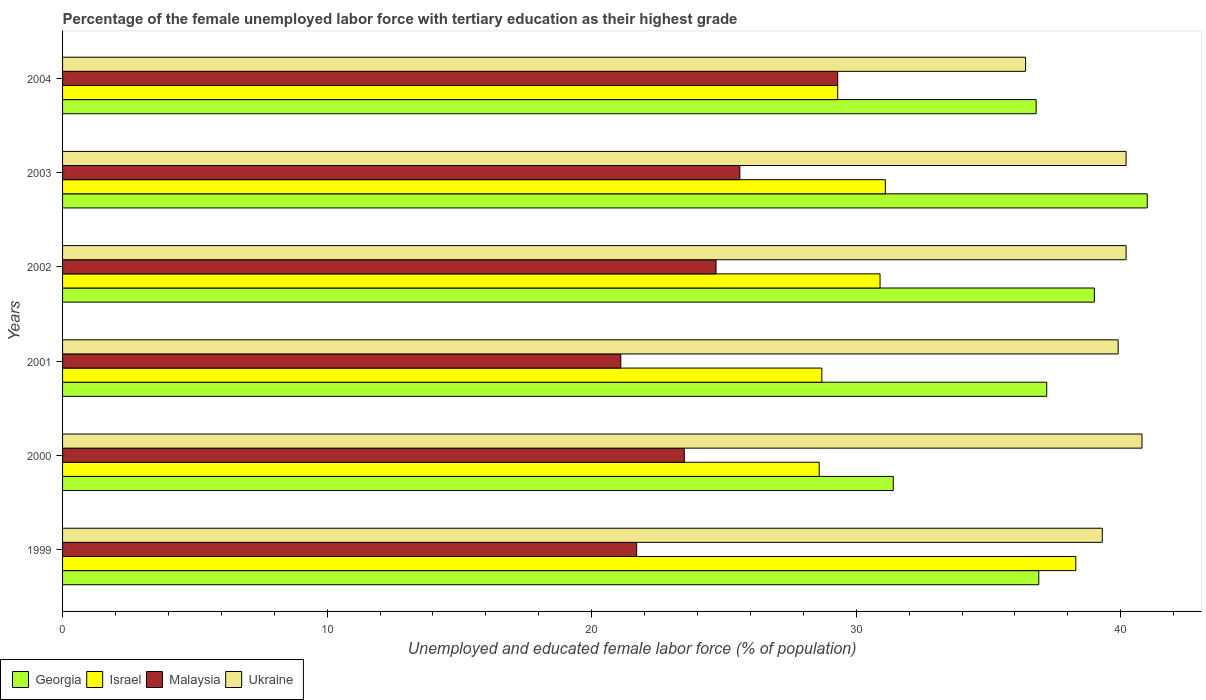How many groups of bars are there?
Provide a succinct answer. 6. In how many cases, is the number of bars for a given year not equal to the number of legend labels?
Ensure brevity in your answer.  0. What is the percentage of the unemployed female labor force with tertiary education in Georgia in 2000?
Make the answer very short. 31.4. Across all years, what is the maximum percentage of the unemployed female labor force with tertiary education in Malaysia?
Make the answer very short. 29.3. Across all years, what is the minimum percentage of the unemployed female labor force with tertiary education in Ukraine?
Ensure brevity in your answer.  36.4. In which year was the percentage of the unemployed female labor force with tertiary education in Israel maximum?
Your response must be concise. 1999. In which year was the percentage of the unemployed female labor force with tertiary education in Israel minimum?
Ensure brevity in your answer.  2000. What is the total percentage of the unemployed female labor force with tertiary education in Malaysia in the graph?
Offer a very short reply. 145.9. What is the difference between the percentage of the unemployed female labor force with tertiary education in Israel in 1999 and that in 2004?
Give a very brief answer. 9. What is the difference between the percentage of the unemployed female labor force with tertiary education in Malaysia in 2003 and the percentage of the unemployed female labor force with tertiary education in Ukraine in 2002?
Make the answer very short. -14.6. What is the average percentage of the unemployed female labor force with tertiary education in Ukraine per year?
Ensure brevity in your answer.  39.47. In the year 2004, what is the difference between the percentage of the unemployed female labor force with tertiary education in Malaysia and percentage of the unemployed female labor force with tertiary education in Ukraine?
Provide a short and direct response. -7.1. What is the ratio of the percentage of the unemployed female labor force with tertiary education in Georgia in 2000 to that in 2001?
Your response must be concise. 0.84. What is the difference between the highest and the lowest percentage of the unemployed female labor force with tertiary education in Malaysia?
Give a very brief answer. 8.2. What does the 1st bar from the top in 2004 represents?
Provide a short and direct response. Ukraine. Is it the case that in every year, the sum of the percentage of the unemployed female labor force with tertiary education in Israel and percentage of the unemployed female labor force with tertiary education in Georgia is greater than the percentage of the unemployed female labor force with tertiary education in Malaysia?
Keep it short and to the point. Yes. How many bars are there?
Your answer should be compact. 24. Are all the bars in the graph horizontal?
Your answer should be compact. Yes. How many years are there in the graph?
Your response must be concise. 6. What is the difference between two consecutive major ticks on the X-axis?
Your answer should be compact. 10. Are the values on the major ticks of X-axis written in scientific E-notation?
Give a very brief answer. No. Does the graph contain grids?
Make the answer very short. No. How many legend labels are there?
Offer a very short reply. 4. What is the title of the graph?
Offer a very short reply. Percentage of the female unemployed labor force with tertiary education as their highest grade. Does "Saudi Arabia" appear as one of the legend labels in the graph?
Provide a short and direct response. No. What is the label or title of the X-axis?
Offer a terse response. Unemployed and educated female labor force (% of population). What is the label or title of the Y-axis?
Ensure brevity in your answer.  Years. What is the Unemployed and educated female labor force (% of population) in Georgia in 1999?
Your answer should be very brief. 36.9. What is the Unemployed and educated female labor force (% of population) in Israel in 1999?
Keep it short and to the point. 38.3. What is the Unemployed and educated female labor force (% of population) in Malaysia in 1999?
Offer a terse response. 21.7. What is the Unemployed and educated female labor force (% of population) in Ukraine in 1999?
Provide a succinct answer. 39.3. What is the Unemployed and educated female labor force (% of population) in Georgia in 2000?
Provide a succinct answer. 31.4. What is the Unemployed and educated female labor force (% of population) in Israel in 2000?
Your answer should be compact. 28.6. What is the Unemployed and educated female labor force (% of population) of Ukraine in 2000?
Provide a short and direct response. 40.8. What is the Unemployed and educated female labor force (% of population) of Georgia in 2001?
Your answer should be very brief. 37.2. What is the Unemployed and educated female labor force (% of population) in Israel in 2001?
Offer a very short reply. 28.7. What is the Unemployed and educated female labor force (% of population) of Malaysia in 2001?
Your answer should be compact. 21.1. What is the Unemployed and educated female labor force (% of population) in Ukraine in 2001?
Offer a terse response. 39.9. What is the Unemployed and educated female labor force (% of population) in Georgia in 2002?
Your response must be concise. 39. What is the Unemployed and educated female labor force (% of population) in Israel in 2002?
Keep it short and to the point. 30.9. What is the Unemployed and educated female labor force (% of population) in Malaysia in 2002?
Offer a terse response. 24.7. What is the Unemployed and educated female labor force (% of population) in Ukraine in 2002?
Offer a very short reply. 40.2. What is the Unemployed and educated female labor force (% of population) of Georgia in 2003?
Keep it short and to the point. 41. What is the Unemployed and educated female labor force (% of population) in Israel in 2003?
Your answer should be compact. 31.1. What is the Unemployed and educated female labor force (% of population) in Malaysia in 2003?
Your response must be concise. 25.6. What is the Unemployed and educated female labor force (% of population) in Ukraine in 2003?
Provide a short and direct response. 40.2. What is the Unemployed and educated female labor force (% of population) of Georgia in 2004?
Offer a very short reply. 36.8. What is the Unemployed and educated female labor force (% of population) of Israel in 2004?
Keep it short and to the point. 29.3. What is the Unemployed and educated female labor force (% of population) of Malaysia in 2004?
Provide a short and direct response. 29.3. What is the Unemployed and educated female labor force (% of population) in Ukraine in 2004?
Your answer should be compact. 36.4. Across all years, what is the maximum Unemployed and educated female labor force (% of population) in Georgia?
Offer a terse response. 41. Across all years, what is the maximum Unemployed and educated female labor force (% of population) of Israel?
Provide a succinct answer. 38.3. Across all years, what is the maximum Unemployed and educated female labor force (% of population) in Malaysia?
Offer a terse response. 29.3. Across all years, what is the maximum Unemployed and educated female labor force (% of population) of Ukraine?
Provide a short and direct response. 40.8. Across all years, what is the minimum Unemployed and educated female labor force (% of population) of Georgia?
Ensure brevity in your answer.  31.4. Across all years, what is the minimum Unemployed and educated female labor force (% of population) in Israel?
Give a very brief answer. 28.6. Across all years, what is the minimum Unemployed and educated female labor force (% of population) in Malaysia?
Provide a short and direct response. 21.1. Across all years, what is the minimum Unemployed and educated female labor force (% of population) of Ukraine?
Ensure brevity in your answer.  36.4. What is the total Unemployed and educated female labor force (% of population) of Georgia in the graph?
Your answer should be very brief. 222.3. What is the total Unemployed and educated female labor force (% of population) of Israel in the graph?
Give a very brief answer. 186.9. What is the total Unemployed and educated female labor force (% of population) in Malaysia in the graph?
Ensure brevity in your answer.  145.9. What is the total Unemployed and educated female labor force (% of population) in Ukraine in the graph?
Make the answer very short. 236.8. What is the difference between the Unemployed and educated female labor force (% of population) in Israel in 1999 and that in 2000?
Provide a succinct answer. 9.7. What is the difference between the Unemployed and educated female labor force (% of population) of Malaysia in 1999 and that in 2000?
Your response must be concise. -1.8. What is the difference between the Unemployed and educated female labor force (% of population) in Ukraine in 1999 and that in 2000?
Ensure brevity in your answer.  -1.5. What is the difference between the Unemployed and educated female labor force (% of population) in Israel in 1999 and that in 2001?
Offer a very short reply. 9.6. What is the difference between the Unemployed and educated female labor force (% of population) of Israel in 1999 and that in 2002?
Make the answer very short. 7.4. What is the difference between the Unemployed and educated female labor force (% of population) of Malaysia in 1999 and that in 2003?
Provide a short and direct response. -3.9. What is the difference between the Unemployed and educated female labor force (% of population) in Ukraine in 1999 and that in 2003?
Offer a terse response. -0.9. What is the difference between the Unemployed and educated female labor force (% of population) of Georgia in 1999 and that in 2004?
Give a very brief answer. 0.1. What is the difference between the Unemployed and educated female labor force (% of population) of Malaysia in 1999 and that in 2004?
Ensure brevity in your answer.  -7.6. What is the difference between the Unemployed and educated female labor force (% of population) in Ukraine in 1999 and that in 2004?
Your response must be concise. 2.9. What is the difference between the Unemployed and educated female labor force (% of population) in Israel in 2000 and that in 2001?
Provide a succinct answer. -0.1. What is the difference between the Unemployed and educated female labor force (% of population) in Malaysia in 2000 and that in 2001?
Make the answer very short. 2.4. What is the difference between the Unemployed and educated female labor force (% of population) in Georgia in 2000 and that in 2002?
Keep it short and to the point. -7.6. What is the difference between the Unemployed and educated female labor force (% of population) of Ukraine in 2000 and that in 2002?
Give a very brief answer. 0.6. What is the difference between the Unemployed and educated female labor force (% of population) in Malaysia in 2000 and that in 2004?
Keep it short and to the point. -5.8. What is the difference between the Unemployed and educated female labor force (% of population) of Ukraine in 2000 and that in 2004?
Keep it short and to the point. 4.4. What is the difference between the Unemployed and educated female labor force (% of population) of Malaysia in 2001 and that in 2002?
Keep it short and to the point. -3.6. What is the difference between the Unemployed and educated female labor force (% of population) of Ukraine in 2001 and that in 2002?
Your answer should be very brief. -0.3. What is the difference between the Unemployed and educated female labor force (% of population) of Georgia in 2001 and that in 2003?
Give a very brief answer. -3.8. What is the difference between the Unemployed and educated female labor force (% of population) of Malaysia in 2001 and that in 2003?
Keep it short and to the point. -4.5. What is the difference between the Unemployed and educated female labor force (% of population) of Ukraine in 2001 and that in 2003?
Provide a short and direct response. -0.3. What is the difference between the Unemployed and educated female labor force (% of population) in Israel in 2001 and that in 2004?
Offer a very short reply. -0.6. What is the difference between the Unemployed and educated female labor force (% of population) of Malaysia in 2001 and that in 2004?
Your answer should be very brief. -8.2. What is the difference between the Unemployed and educated female labor force (% of population) of Ukraine in 2001 and that in 2004?
Keep it short and to the point. 3.5. What is the difference between the Unemployed and educated female labor force (% of population) in Georgia in 2002 and that in 2003?
Your response must be concise. -2. What is the difference between the Unemployed and educated female labor force (% of population) in Israel in 2002 and that in 2003?
Make the answer very short. -0.2. What is the difference between the Unemployed and educated female labor force (% of population) of Malaysia in 2002 and that in 2004?
Make the answer very short. -4.6. What is the difference between the Unemployed and educated female labor force (% of population) of Ukraine in 2002 and that in 2004?
Your response must be concise. 3.8. What is the difference between the Unemployed and educated female labor force (% of population) in Malaysia in 2003 and that in 2004?
Your response must be concise. -3.7. What is the difference between the Unemployed and educated female labor force (% of population) of Ukraine in 2003 and that in 2004?
Provide a succinct answer. 3.8. What is the difference between the Unemployed and educated female labor force (% of population) of Georgia in 1999 and the Unemployed and educated female labor force (% of population) of Ukraine in 2000?
Make the answer very short. -3.9. What is the difference between the Unemployed and educated female labor force (% of population) of Israel in 1999 and the Unemployed and educated female labor force (% of population) of Malaysia in 2000?
Your response must be concise. 14.8. What is the difference between the Unemployed and educated female labor force (% of population) in Israel in 1999 and the Unemployed and educated female labor force (% of population) in Ukraine in 2000?
Your answer should be compact. -2.5. What is the difference between the Unemployed and educated female labor force (% of population) in Malaysia in 1999 and the Unemployed and educated female labor force (% of population) in Ukraine in 2000?
Give a very brief answer. -19.1. What is the difference between the Unemployed and educated female labor force (% of population) in Georgia in 1999 and the Unemployed and educated female labor force (% of population) in Ukraine in 2001?
Your answer should be very brief. -3. What is the difference between the Unemployed and educated female labor force (% of population) in Israel in 1999 and the Unemployed and educated female labor force (% of population) in Malaysia in 2001?
Make the answer very short. 17.2. What is the difference between the Unemployed and educated female labor force (% of population) in Malaysia in 1999 and the Unemployed and educated female labor force (% of population) in Ukraine in 2001?
Keep it short and to the point. -18.2. What is the difference between the Unemployed and educated female labor force (% of population) of Israel in 1999 and the Unemployed and educated female labor force (% of population) of Malaysia in 2002?
Give a very brief answer. 13.6. What is the difference between the Unemployed and educated female labor force (% of population) of Malaysia in 1999 and the Unemployed and educated female labor force (% of population) of Ukraine in 2002?
Your answer should be compact. -18.5. What is the difference between the Unemployed and educated female labor force (% of population) of Georgia in 1999 and the Unemployed and educated female labor force (% of population) of Israel in 2003?
Your answer should be very brief. 5.8. What is the difference between the Unemployed and educated female labor force (% of population) of Israel in 1999 and the Unemployed and educated female labor force (% of population) of Ukraine in 2003?
Make the answer very short. -1.9. What is the difference between the Unemployed and educated female labor force (% of population) in Malaysia in 1999 and the Unemployed and educated female labor force (% of population) in Ukraine in 2003?
Your response must be concise. -18.5. What is the difference between the Unemployed and educated female labor force (% of population) in Georgia in 1999 and the Unemployed and educated female labor force (% of population) in Israel in 2004?
Provide a succinct answer. 7.6. What is the difference between the Unemployed and educated female labor force (% of population) in Georgia in 1999 and the Unemployed and educated female labor force (% of population) in Malaysia in 2004?
Offer a terse response. 7.6. What is the difference between the Unemployed and educated female labor force (% of population) of Malaysia in 1999 and the Unemployed and educated female labor force (% of population) of Ukraine in 2004?
Give a very brief answer. -14.7. What is the difference between the Unemployed and educated female labor force (% of population) of Georgia in 2000 and the Unemployed and educated female labor force (% of population) of Ukraine in 2001?
Your answer should be compact. -8.5. What is the difference between the Unemployed and educated female labor force (% of population) of Israel in 2000 and the Unemployed and educated female labor force (% of population) of Malaysia in 2001?
Your answer should be very brief. 7.5. What is the difference between the Unemployed and educated female labor force (% of population) of Israel in 2000 and the Unemployed and educated female labor force (% of population) of Ukraine in 2001?
Your response must be concise. -11.3. What is the difference between the Unemployed and educated female labor force (% of population) in Malaysia in 2000 and the Unemployed and educated female labor force (% of population) in Ukraine in 2001?
Make the answer very short. -16.4. What is the difference between the Unemployed and educated female labor force (% of population) in Israel in 2000 and the Unemployed and educated female labor force (% of population) in Malaysia in 2002?
Offer a terse response. 3.9. What is the difference between the Unemployed and educated female labor force (% of population) in Malaysia in 2000 and the Unemployed and educated female labor force (% of population) in Ukraine in 2002?
Your answer should be very brief. -16.7. What is the difference between the Unemployed and educated female labor force (% of population) in Georgia in 2000 and the Unemployed and educated female labor force (% of population) in Israel in 2003?
Offer a terse response. 0.3. What is the difference between the Unemployed and educated female labor force (% of population) of Georgia in 2000 and the Unemployed and educated female labor force (% of population) of Malaysia in 2003?
Keep it short and to the point. 5.8. What is the difference between the Unemployed and educated female labor force (% of population) in Georgia in 2000 and the Unemployed and educated female labor force (% of population) in Ukraine in 2003?
Provide a succinct answer. -8.8. What is the difference between the Unemployed and educated female labor force (% of population) of Malaysia in 2000 and the Unemployed and educated female labor force (% of population) of Ukraine in 2003?
Your answer should be compact. -16.7. What is the difference between the Unemployed and educated female labor force (% of population) of Georgia in 2000 and the Unemployed and educated female labor force (% of population) of Israel in 2004?
Your answer should be compact. 2.1. What is the difference between the Unemployed and educated female labor force (% of population) in Georgia in 2000 and the Unemployed and educated female labor force (% of population) in Ukraine in 2004?
Give a very brief answer. -5. What is the difference between the Unemployed and educated female labor force (% of population) of Israel in 2000 and the Unemployed and educated female labor force (% of population) of Ukraine in 2004?
Your answer should be compact. -7.8. What is the difference between the Unemployed and educated female labor force (% of population) in Malaysia in 2000 and the Unemployed and educated female labor force (% of population) in Ukraine in 2004?
Provide a short and direct response. -12.9. What is the difference between the Unemployed and educated female labor force (% of population) of Georgia in 2001 and the Unemployed and educated female labor force (% of population) of Malaysia in 2002?
Your answer should be very brief. 12.5. What is the difference between the Unemployed and educated female labor force (% of population) in Georgia in 2001 and the Unemployed and educated female labor force (% of population) in Ukraine in 2002?
Ensure brevity in your answer.  -3. What is the difference between the Unemployed and educated female labor force (% of population) in Israel in 2001 and the Unemployed and educated female labor force (% of population) in Malaysia in 2002?
Keep it short and to the point. 4. What is the difference between the Unemployed and educated female labor force (% of population) in Israel in 2001 and the Unemployed and educated female labor force (% of population) in Ukraine in 2002?
Offer a very short reply. -11.5. What is the difference between the Unemployed and educated female labor force (% of population) in Malaysia in 2001 and the Unemployed and educated female labor force (% of population) in Ukraine in 2002?
Provide a short and direct response. -19.1. What is the difference between the Unemployed and educated female labor force (% of population) in Georgia in 2001 and the Unemployed and educated female labor force (% of population) in Israel in 2003?
Provide a short and direct response. 6.1. What is the difference between the Unemployed and educated female labor force (% of population) of Georgia in 2001 and the Unemployed and educated female labor force (% of population) of Malaysia in 2003?
Provide a succinct answer. 11.6. What is the difference between the Unemployed and educated female labor force (% of population) in Israel in 2001 and the Unemployed and educated female labor force (% of population) in Malaysia in 2003?
Give a very brief answer. 3.1. What is the difference between the Unemployed and educated female labor force (% of population) of Israel in 2001 and the Unemployed and educated female labor force (% of population) of Ukraine in 2003?
Keep it short and to the point. -11.5. What is the difference between the Unemployed and educated female labor force (% of population) in Malaysia in 2001 and the Unemployed and educated female labor force (% of population) in Ukraine in 2003?
Your answer should be very brief. -19.1. What is the difference between the Unemployed and educated female labor force (% of population) in Malaysia in 2001 and the Unemployed and educated female labor force (% of population) in Ukraine in 2004?
Your response must be concise. -15.3. What is the difference between the Unemployed and educated female labor force (% of population) of Israel in 2002 and the Unemployed and educated female labor force (% of population) of Malaysia in 2003?
Provide a succinct answer. 5.3. What is the difference between the Unemployed and educated female labor force (% of population) in Israel in 2002 and the Unemployed and educated female labor force (% of population) in Ukraine in 2003?
Make the answer very short. -9.3. What is the difference between the Unemployed and educated female labor force (% of population) of Malaysia in 2002 and the Unemployed and educated female labor force (% of population) of Ukraine in 2003?
Your answer should be very brief. -15.5. What is the difference between the Unemployed and educated female labor force (% of population) of Israel in 2002 and the Unemployed and educated female labor force (% of population) of Ukraine in 2004?
Offer a terse response. -5.5. What is the difference between the Unemployed and educated female labor force (% of population) of Georgia in 2003 and the Unemployed and educated female labor force (% of population) of Ukraine in 2004?
Keep it short and to the point. 4.6. What is the difference between the Unemployed and educated female labor force (% of population) in Malaysia in 2003 and the Unemployed and educated female labor force (% of population) in Ukraine in 2004?
Provide a short and direct response. -10.8. What is the average Unemployed and educated female labor force (% of population) in Georgia per year?
Make the answer very short. 37.05. What is the average Unemployed and educated female labor force (% of population) in Israel per year?
Offer a very short reply. 31.15. What is the average Unemployed and educated female labor force (% of population) of Malaysia per year?
Offer a very short reply. 24.32. What is the average Unemployed and educated female labor force (% of population) of Ukraine per year?
Ensure brevity in your answer.  39.47. In the year 1999, what is the difference between the Unemployed and educated female labor force (% of population) in Georgia and Unemployed and educated female labor force (% of population) in Israel?
Provide a short and direct response. -1.4. In the year 1999, what is the difference between the Unemployed and educated female labor force (% of population) in Malaysia and Unemployed and educated female labor force (% of population) in Ukraine?
Provide a succinct answer. -17.6. In the year 2000, what is the difference between the Unemployed and educated female labor force (% of population) of Georgia and Unemployed and educated female labor force (% of population) of Malaysia?
Provide a short and direct response. 7.9. In the year 2000, what is the difference between the Unemployed and educated female labor force (% of population) of Georgia and Unemployed and educated female labor force (% of population) of Ukraine?
Make the answer very short. -9.4. In the year 2000, what is the difference between the Unemployed and educated female labor force (% of population) of Israel and Unemployed and educated female labor force (% of population) of Malaysia?
Keep it short and to the point. 5.1. In the year 2000, what is the difference between the Unemployed and educated female labor force (% of population) in Malaysia and Unemployed and educated female labor force (% of population) in Ukraine?
Your answer should be compact. -17.3. In the year 2001, what is the difference between the Unemployed and educated female labor force (% of population) of Georgia and Unemployed and educated female labor force (% of population) of Israel?
Ensure brevity in your answer.  8.5. In the year 2001, what is the difference between the Unemployed and educated female labor force (% of population) of Georgia and Unemployed and educated female labor force (% of population) of Ukraine?
Provide a short and direct response. -2.7. In the year 2001, what is the difference between the Unemployed and educated female labor force (% of population) in Israel and Unemployed and educated female labor force (% of population) in Malaysia?
Provide a short and direct response. 7.6. In the year 2001, what is the difference between the Unemployed and educated female labor force (% of population) in Israel and Unemployed and educated female labor force (% of population) in Ukraine?
Your answer should be compact. -11.2. In the year 2001, what is the difference between the Unemployed and educated female labor force (% of population) in Malaysia and Unemployed and educated female labor force (% of population) in Ukraine?
Provide a short and direct response. -18.8. In the year 2002, what is the difference between the Unemployed and educated female labor force (% of population) of Georgia and Unemployed and educated female labor force (% of population) of Malaysia?
Offer a very short reply. 14.3. In the year 2002, what is the difference between the Unemployed and educated female labor force (% of population) of Israel and Unemployed and educated female labor force (% of population) of Malaysia?
Your answer should be very brief. 6.2. In the year 2002, what is the difference between the Unemployed and educated female labor force (% of population) of Israel and Unemployed and educated female labor force (% of population) of Ukraine?
Offer a terse response. -9.3. In the year 2002, what is the difference between the Unemployed and educated female labor force (% of population) in Malaysia and Unemployed and educated female labor force (% of population) in Ukraine?
Offer a very short reply. -15.5. In the year 2003, what is the difference between the Unemployed and educated female labor force (% of population) in Georgia and Unemployed and educated female labor force (% of population) in Malaysia?
Ensure brevity in your answer.  15.4. In the year 2003, what is the difference between the Unemployed and educated female labor force (% of population) of Israel and Unemployed and educated female labor force (% of population) of Malaysia?
Your answer should be compact. 5.5. In the year 2003, what is the difference between the Unemployed and educated female labor force (% of population) in Malaysia and Unemployed and educated female labor force (% of population) in Ukraine?
Your answer should be compact. -14.6. In the year 2004, what is the difference between the Unemployed and educated female labor force (% of population) of Georgia and Unemployed and educated female labor force (% of population) of Ukraine?
Keep it short and to the point. 0.4. In the year 2004, what is the difference between the Unemployed and educated female labor force (% of population) of Israel and Unemployed and educated female labor force (% of population) of Malaysia?
Provide a succinct answer. 0. In the year 2004, what is the difference between the Unemployed and educated female labor force (% of population) in Israel and Unemployed and educated female labor force (% of population) in Ukraine?
Your response must be concise. -7.1. What is the ratio of the Unemployed and educated female labor force (% of population) of Georgia in 1999 to that in 2000?
Offer a terse response. 1.18. What is the ratio of the Unemployed and educated female labor force (% of population) of Israel in 1999 to that in 2000?
Your response must be concise. 1.34. What is the ratio of the Unemployed and educated female labor force (% of population) of Malaysia in 1999 to that in 2000?
Provide a short and direct response. 0.92. What is the ratio of the Unemployed and educated female labor force (% of population) of Ukraine in 1999 to that in 2000?
Ensure brevity in your answer.  0.96. What is the ratio of the Unemployed and educated female labor force (% of population) in Georgia in 1999 to that in 2001?
Your answer should be very brief. 0.99. What is the ratio of the Unemployed and educated female labor force (% of population) of Israel in 1999 to that in 2001?
Your answer should be very brief. 1.33. What is the ratio of the Unemployed and educated female labor force (% of population) in Malaysia in 1999 to that in 2001?
Your answer should be compact. 1.03. What is the ratio of the Unemployed and educated female labor force (% of population) of Ukraine in 1999 to that in 2001?
Offer a terse response. 0.98. What is the ratio of the Unemployed and educated female labor force (% of population) of Georgia in 1999 to that in 2002?
Keep it short and to the point. 0.95. What is the ratio of the Unemployed and educated female labor force (% of population) in Israel in 1999 to that in 2002?
Keep it short and to the point. 1.24. What is the ratio of the Unemployed and educated female labor force (% of population) in Malaysia in 1999 to that in 2002?
Make the answer very short. 0.88. What is the ratio of the Unemployed and educated female labor force (% of population) of Ukraine in 1999 to that in 2002?
Ensure brevity in your answer.  0.98. What is the ratio of the Unemployed and educated female labor force (% of population) of Georgia in 1999 to that in 2003?
Give a very brief answer. 0.9. What is the ratio of the Unemployed and educated female labor force (% of population) in Israel in 1999 to that in 2003?
Offer a very short reply. 1.23. What is the ratio of the Unemployed and educated female labor force (% of population) in Malaysia in 1999 to that in 2003?
Ensure brevity in your answer.  0.85. What is the ratio of the Unemployed and educated female labor force (% of population) of Ukraine in 1999 to that in 2003?
Provide a succinct answer. 0.98. What is the ratio of the Unemployed and educated female labor force (% of population) in Georgia in 1999 to that in 2004?
Your answer should be compact. 1. What is the ratio of the Unemployed and educated female labor force (% of population) in Israel in 1999 to that in 2004?
Make the answer very short. 1.31. What is the ratio of the Unemployed and educated female labor force (% of population) of Malaysia in 1999 to that in 2004?
Ensure brevity in your answer.  0.74. What is the ratio of the Unemployed and educated female labor force (% of population) in Ukraine in 1999 to that in 2004?
Keep it short and to the point. 1.08. What is the ratio of the Unemployed and educated female labor force (% of population) of Georgia in 2000 to that in 2001?
Your answer should be compact. 0.84. What is the ratio of the Unemployed and educated female labor force (% of population) of Israel in 2000 to that in 2001?
Provide a short and direct response. 1. What is the ratio of the Unemployed and educated female labor force (% of population) in Malaysia in 2000 to that in 2001?
Your answer should be very brief. 1.11. What is the ratio of the Unemployed and educated female labor force (% of population) in Ukraine in 2000 to that in 2001?
Your answer should be very brief. 1.02. What is the ratio of the Unemployed and educated female labor force (% of population) of Georgia in 2000 to that in 2002?
Keep it short and to the point. 0.81. What is the ratio of the Unemployed and educated female labor force (% of population) in Israel in 2000 to that in 2002?
Your answer should be very brief. 0.93. What is the ratio of the Unemployed and educated female labor force (% of population) of Malaysia in 2000 to that in 2002?
Provide a succinct answer. 0.95. What is the ratio of the Unemployed and educated female labor force (% of population) in Ukraine in 2000 to that in 2002?
Offer a very short reply. 1.01. What is the ratio of the Unemployed and educated female labor force (% of population) in Georgia in 2000 to that in 2003?
Your answer should be compact. 0.77. What is the ratio of the Unemployed and educated female labor force (% of population) in Israel in 2000 to that in 2003?
Your answer should be very brief. 0.92. What is the ratio of the Unemployed and educated female labor force (% of population) of Malaysia in 2000 to that in 2003?
Your answer should be very brief. 0.92. What is the ratio of the Unemployed and educated female labor force (% of population) in Ukraine in 2000 to that in 2003?
Ensure brevity in your answer.  1.01. What is the ratio of the Unemployed and educated female labor force (% of population) of Georgia in 2000 to that in 2004?
Provide a short and direct response. 0.85. What is the ratio of the Unemployed and educated female labor force (% of population) in Israel in 2000 to that in 2004?
Keep it short and to the point. 0.98. What is the ratio of the Unemployed and educated female labor force (% of population) in Malaysia in 2000 to that in 2004?
Ensure brevity in your answer.  0.8. What is the ratio of the Unemployed and educated female labor force (% of population) of Ukraine in 2000 to that in 2004?
Provide a succinct answer. 1.12. What is the ratio of the Unemployed and educated female labor force (% of population) of Georgia in 2001 to that in 2002?
Your response must be concise. 0.95. What is the ratio of the Unemployed and educated female labor force (% of population) in Israel in 2001 to that in 2002?
Your answer should be compact. 0.93. What is the ratio of the Unemployed and educated female labor force (% of population) of Malaysia in 2001 to that in 2002?
Provide a succinct answer. 0.85. What is the ratio of the Unemployed and educated female labor force (% of population) in Ukraine in 2001 to that in 2002?
Your answer should be compact. 0.99. What is the ratio of the Unemployed and educated female labor force (% of population) in Georgia in 2001 to that in 2003?
Your answer should be compact. 0.91. What is the ratio of the Unemployed and educated female labor force (% of population) in Israel in 2001 to that in 2003?
Offer a very short reply. 0.92. What is the ratio of the Unemployed and educated female labor force (% of population) in Malaysia in 2001 to that in 2003?
Keep it short and to the point. 0.82. What is the ratio of the Unemployed and educated female labor force (% of population) of Ukraine in 2001 to that in 2003?
Make the answer very short. 0.99. What is the ratio of the Unemployed and educated female labor force (% of population) of Georgia in 2001 to that in 2004?
Your response must be concise. 1.01. What is the ratio of the Unemployed and educated female labor force (% of population) of Israel in 2001 to that in 2004?
Ensure brevity in your answer.  0.98. What is the ratio of the Unemployed and educated female labor force (% of population) in Malaysia in 2001 to that in 2004?
Your answer should be compact. 0.72. What is the ratio of the Unemployed and educated female labor force (% of population) of Ukraine in 2001 to that in 2004?
Provide a short and direct response. 1.1. What is the ratio of the Unemployed and educated female labor force (% of population) of Georgia in 2002 to that in 2003?
Offer a very short reply. 0.95. What is the ratio of the Unemployed and educated female labor force (% of population) of Israel in 2002 to that in 2003?
Give a very brief answer. 0.99. What is the ratio of the Unemployed and educated female labor force (% of population) of Malaysia in 2002 to that in 2003?
Your answer should be compact. 0.96. What is the ratio of the Unemployed and educated female labor force (% of population) of Georgia in 2002 to that in 2004?
Provide a short and direct response. 1.06. What is the ratio of the Unemployed and educated female labor force (% of population) of Israel in 2002 to that in 2004?
Your answer should be very brief. 1.05. What is the ratio of the Unemployed and educated female labor force (% of population) in Malaysia in 2002 to that in 2004?
Your answer should be very brief. 0.84. What is the ratio of the Unemployed and educated female labor force (% of population) in Ukraine in 2002 to that in 2004?
Your response must be concise. 1.1. What is the ratio of the Unemployed and educated female labor force (% of population) in Georgia in 2003 to that in 2004?
Your response must be concise. 1.11. What is the ratio of the Unemployed and educated female labor force (% of population) in Israel in 2003 to that in 2004?
Your response must be concise. 1.06. What is the ratio of the Unemployed and educated female labor force (% of population) of Malaysia in 2003 to that in 2004?
Give a very brief answer. 0.87. What is the ratio of the Unemployed and educated female labor force (% of population) in Ukraine in 2003 to that in 2004?
Ensure brevity in your answer.  1.1. What is the difference between the highest and the second highest Unemployed and educated female labor force (% of population) of Malaysia?
Make the answer very short. 3.7. What is the difference between the highest and the lowest Unemployed and educated female labor force (% of population) of Georgia?
Your answer should be compact. 9.6. What is the difference between the highest and the lowest Unemployed and educated female labor force (% of population) of Ukraine?
Offer a very short reply. 4.4. 